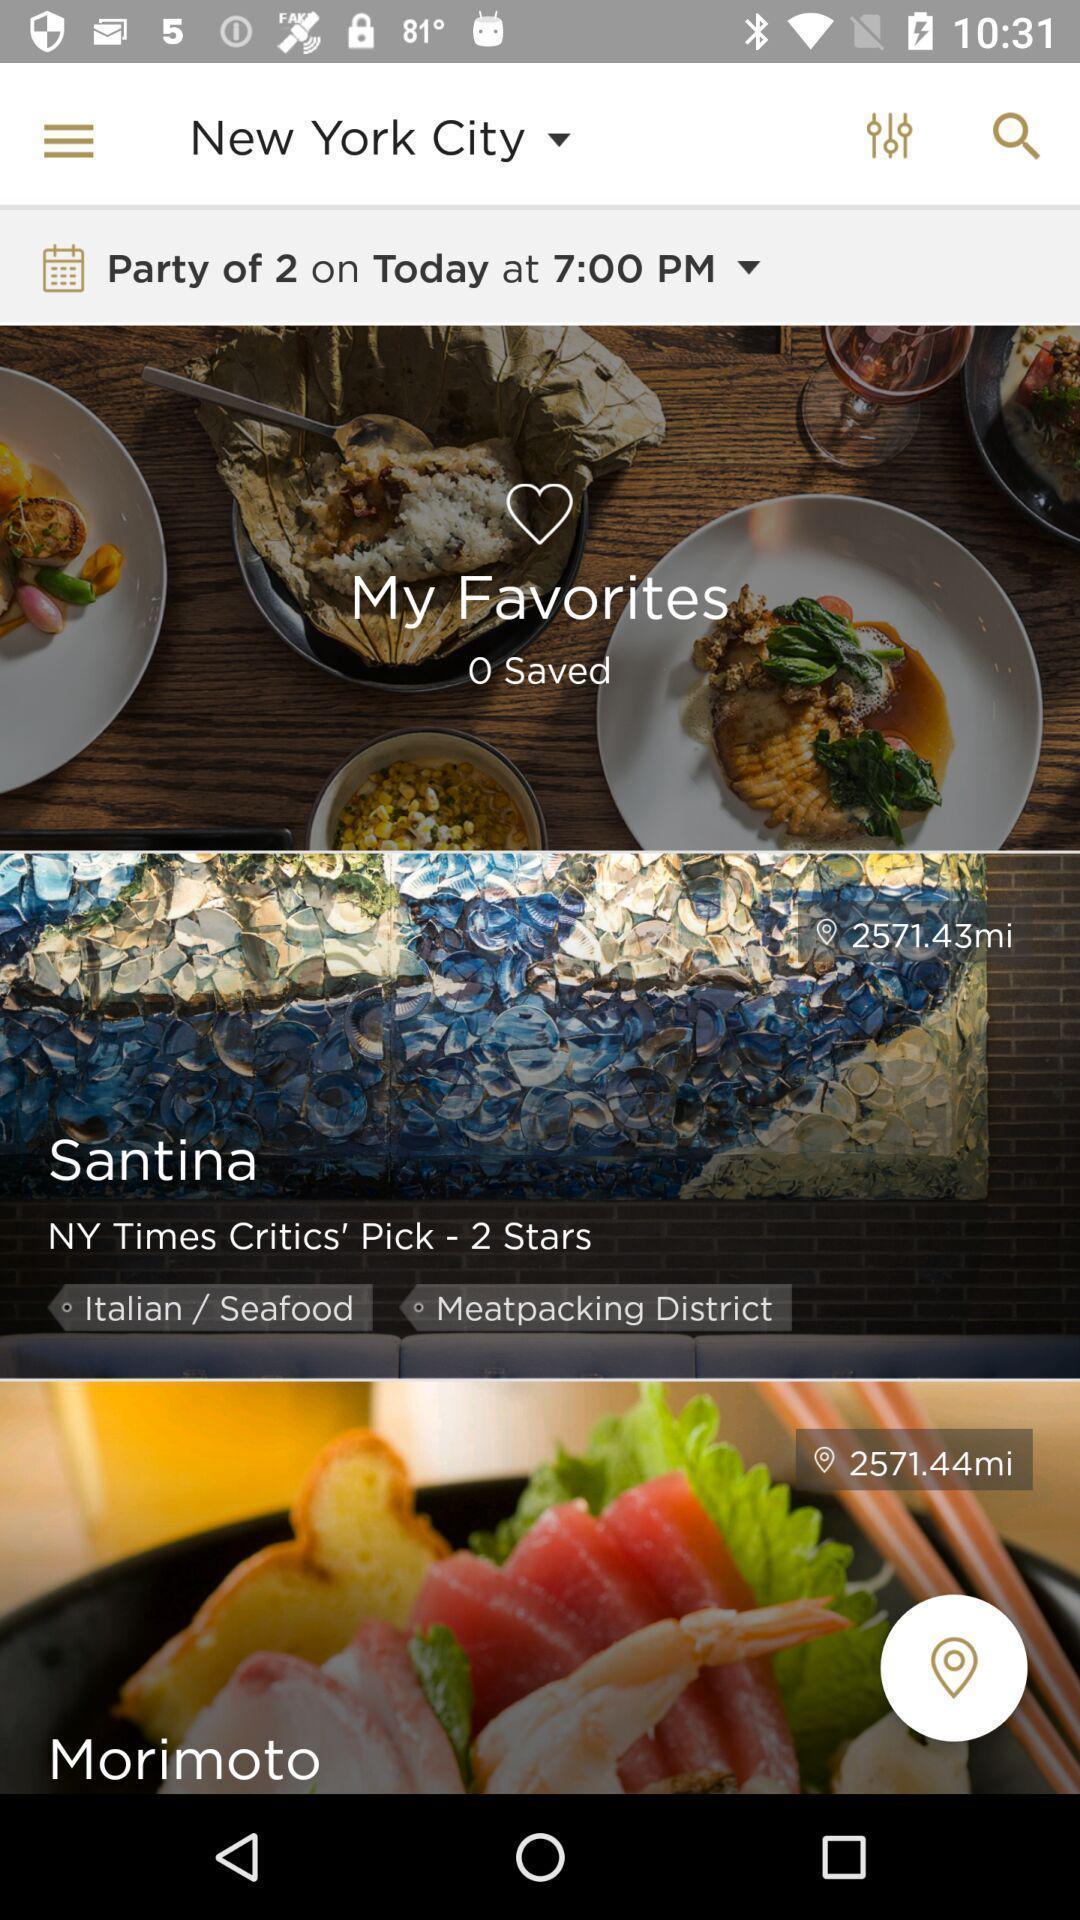Explain the elements present in this screenshot. Result page showing restaurant in a food app. 